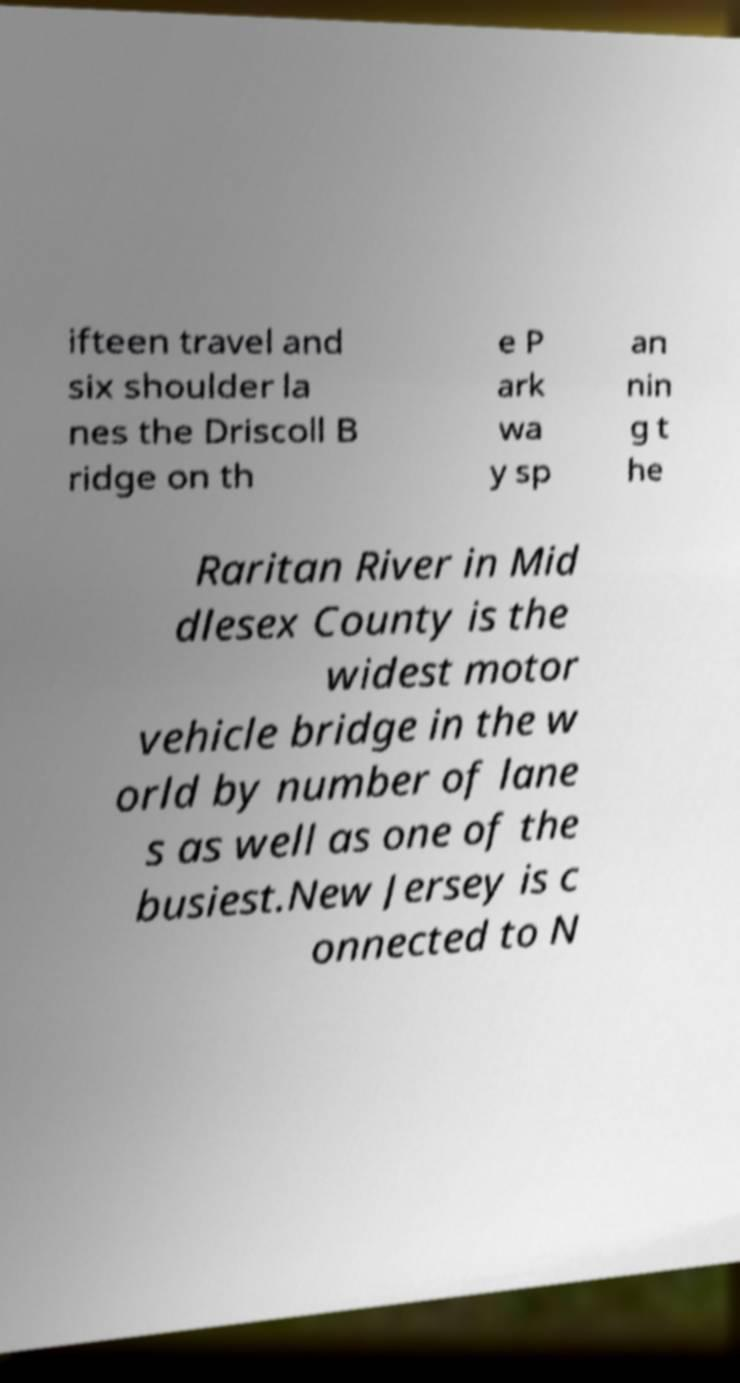There's text embedded in this image that I need extracted. Can you transcribe it verbatim? ifteen travel and six shoulder la nes the Driscoll B ridge on th e P ark wa y sp an nin g t he Raritan River in Mid dlesex County is the widest motor vehicle bridge in the w orld by number of lane s as well as one of the busiest.New Jersey is c onnected to N 